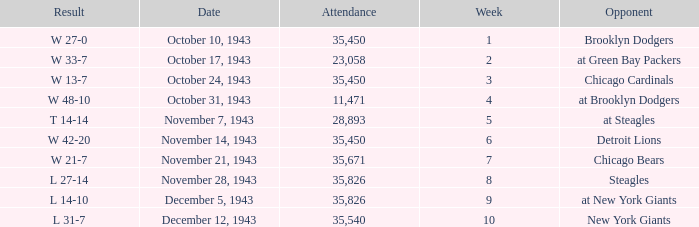How many attendances have w 48-10 as the result? 11471.0. 